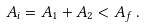<formula> <loc_0><loc_0><loc_500><loc_500>A _ { i } = A _ { 1 } + A _ { 2 } < A _ { f } \, .</formula> 